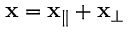<formula> <loc_0><loc_0><loc_500><loc_500>{ x } = { x } _ { \| } + { x } _ { \perp }</formula> 